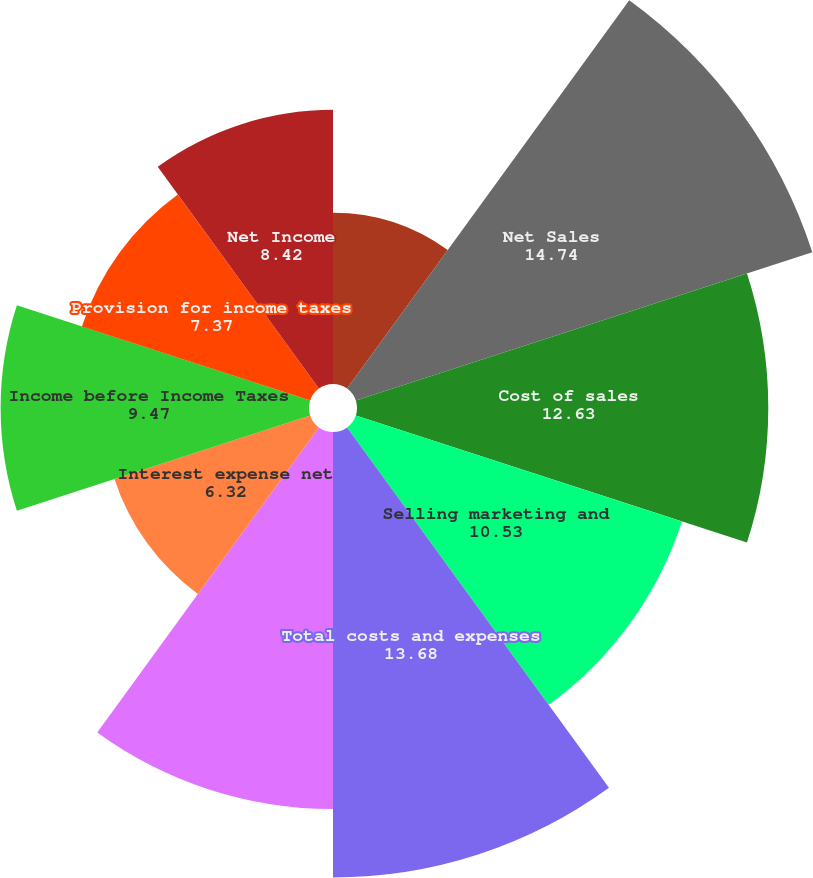Convert chart. <chart><loc_0><loc_0><loc_500><loc_500><pie_chart><fcel>For the years ended December<fcel>Net Sales<fcel>Cost of sales<fcel>Selling marketing and<fcel>Total costs and expenses<fcel>Income before Interest and<fcel>Interest expense net<fcel>Income before Income Taxes<fcel>Provision for income taxes<fcel>Net Income<nl><fcel>5.26%<fcel>14.74%<fcel>12.63%<fcel>10.53%<fcel>13.68%<fcel>11.58%<fcel>6.32%<fcel>9.47%<fcel>7.37%<fcel>8.42%<nl></chart> 